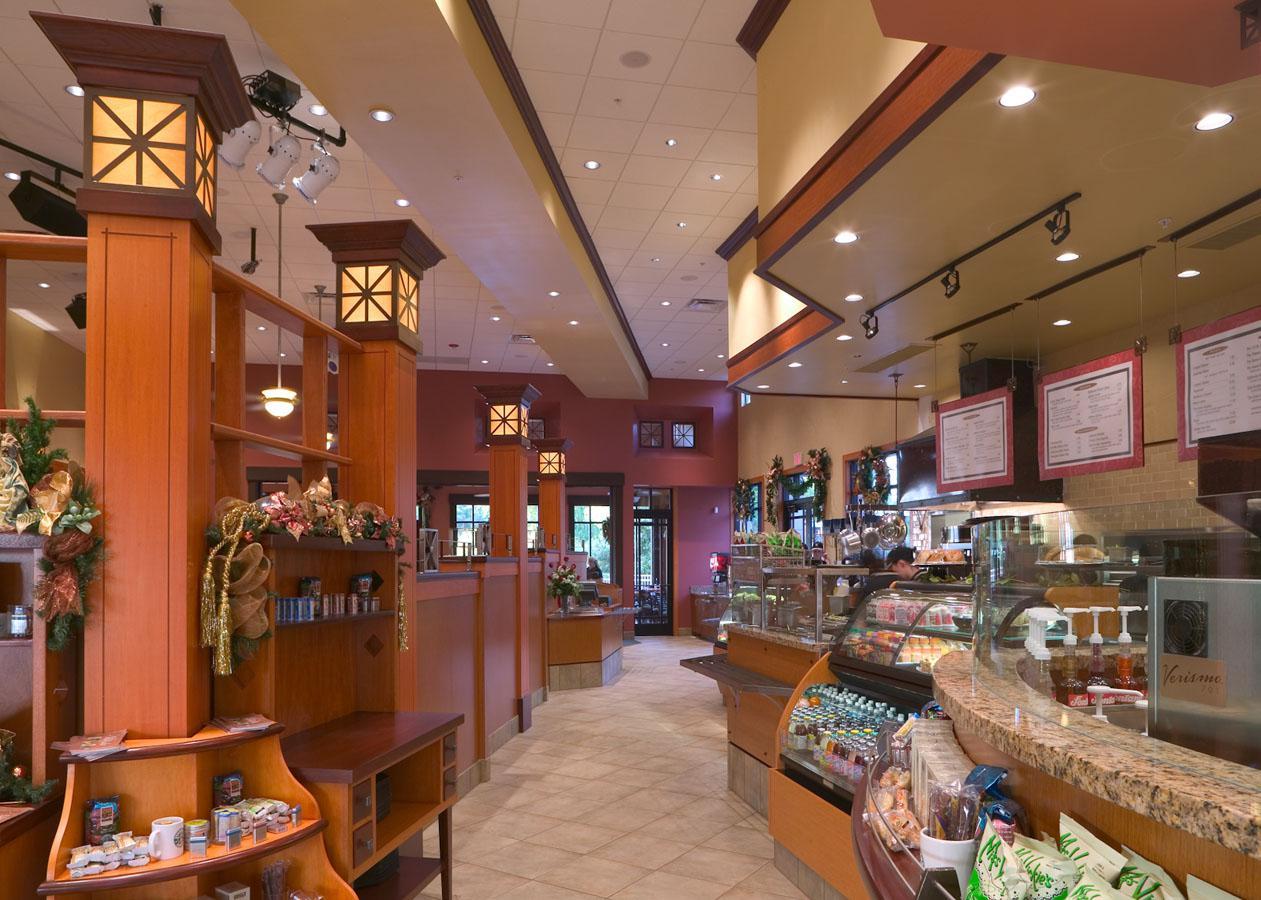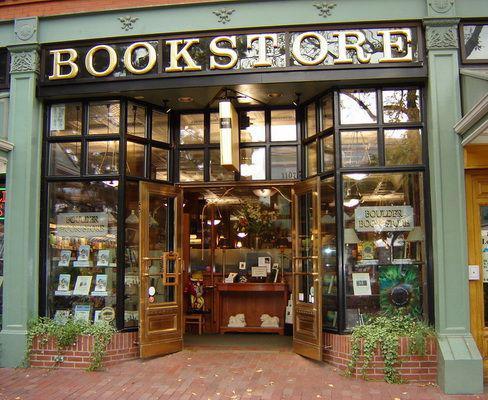The first image is the image on the left, the second image is the image on the right. For the images displayed, is the sentence "A bookstore has a curved staircase that leads to a higher floor." factually correct? Answer yes or no. No. The first image is the image on the left, the second image is the image on the right. Given the left and right images, does the statement "The front of the bookstore is painted green." hold true? Answer yes or no. Yes. 